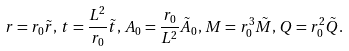Convert formula to latex. <formula><loc_0><loc_0><loc_500><loc_500>r = r _ { 0 } \tilde { r } , \, t = \frac { L ^ { 2 } } { r _ { 0 } } \tilde { t } , \, A _ { 0 } = \frac { r _ { 0 } } { L ^ { 2 } } \tilde { A } _ { 0 } , \, M = r _ { 0 } ^ { 3 } \tilde { M } , \, Q = r _ { 0 } ^ { 2 } \tilde { Q } .</formula> 